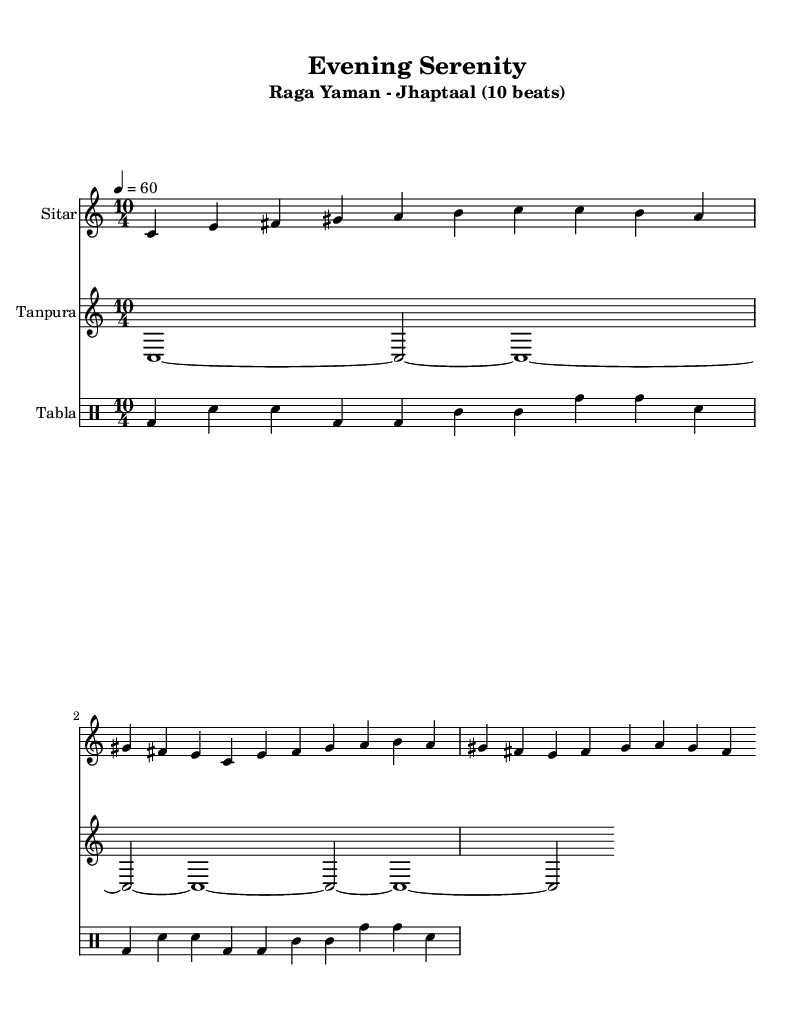What is the key signature of this music? The key signature is indicated at the beginning of the score, which shows that it is in C major. C major has no sharps or flats.
Answer: C major What is the time signature of this piece? The time signature is shown in the score as 10/4, which means there are ten beats in each measure and the quarter note receives one beat.
Answer: 10/4 What is the tempo marking for this composition? The tempo is written in the score, specifying that the piece should be played at a speed of quarter note equals 60 beats per minute.
Answer: 60 What is the main instrument used for the melody? The main instrument for the melody is labeled as "Sitar" in the score, indicating that it plays the primary melodic line.
Answer: Sitar How many beats are there in each cycle of the tabla rhythm? The rhythm is composed in a way that aligns with the time signature, and since the time signature is 10/4, it indicates there are ten beats per cycle.
Answer: 10 What type of raga is this composition based on? The title includes the term "Raga Yaman", which identifies it as an Indian classical raga typically used in evening performances.
Answer: Raga Yaman Which rhythmic cycle is used in this piece? The piece uses a rhythmic cycle called Jhaptaal, which is commonly played in a 10-beat structure in Indian classical music.
Answer: Jhaptaal 